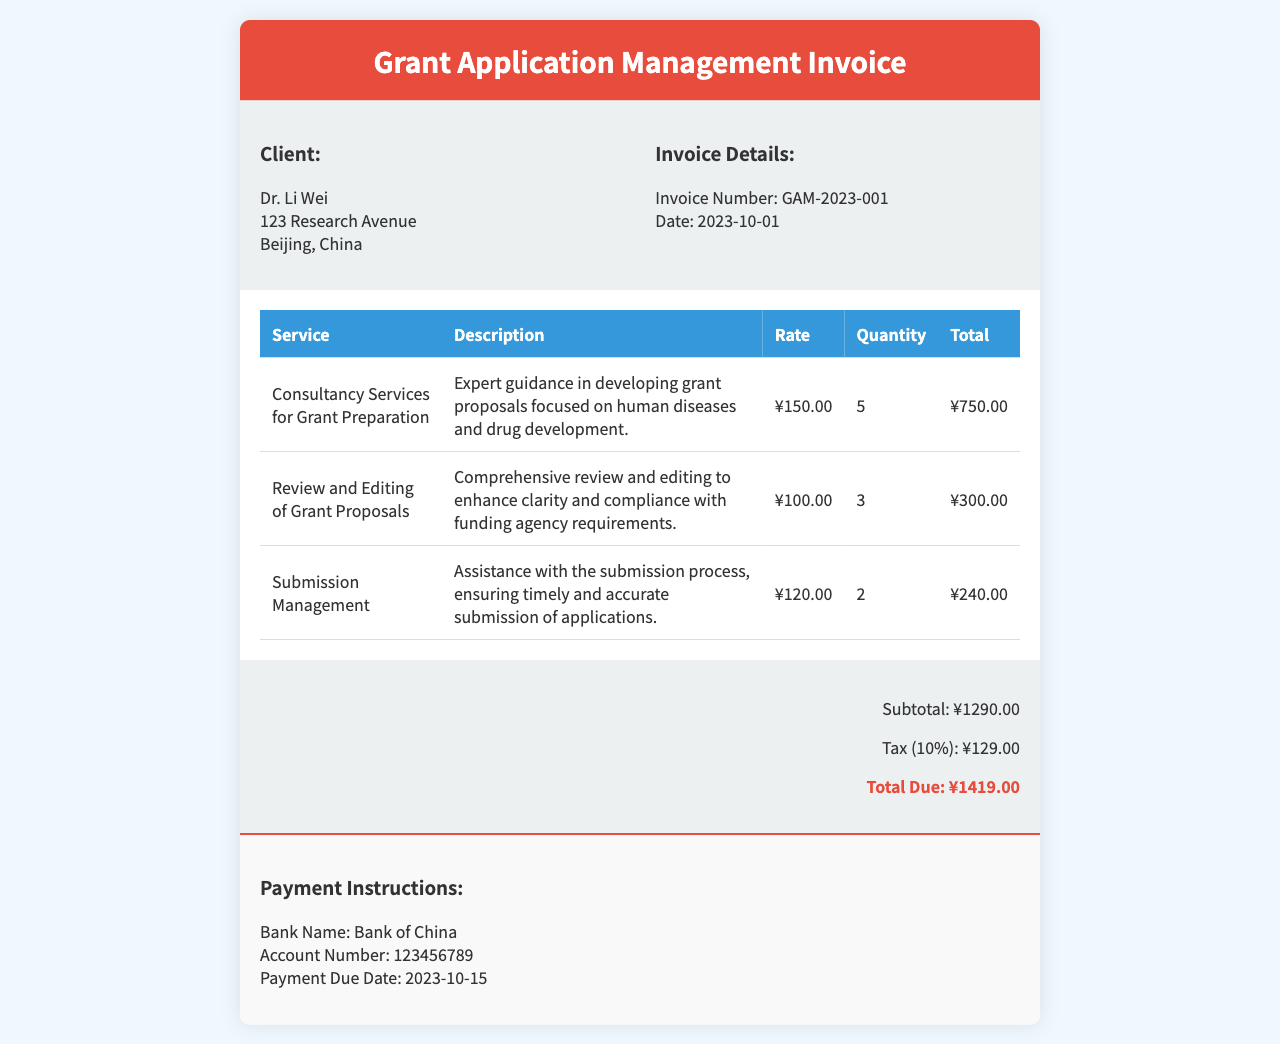What is the name of the client? The client's name is mentioned in the invoice details.
Answer: Dr. Li Wei What is the invoice number? The invoice number is clearly stated in the invoice details section.
Answer: GAM-2023-001 What is the subtotal amount? The subtotal is provided in the total section of the invoice.
Answer: ¥1290.00 How much is the tax? The tax amount is specified in the total section as well.
Answer: ¥129.00 What is the total due? The total due is highlighted in the total section of the invoice.
Answer: ¥1419.00 How many services are listed in the document? The document lists three different services under the services section.
Answer: 3 What type of consultancy services are offered? The service description includes details about the type of consultancy provided.
Answer: Grant Preparation When is the payment due date? The payment due date is mentioned in the payment instructions section.
Answer: 2023-10-15 What bank is mentioned for payment? The bank name is highlighted in the payment instructions area of the invoice.
Answer: Bank of China 